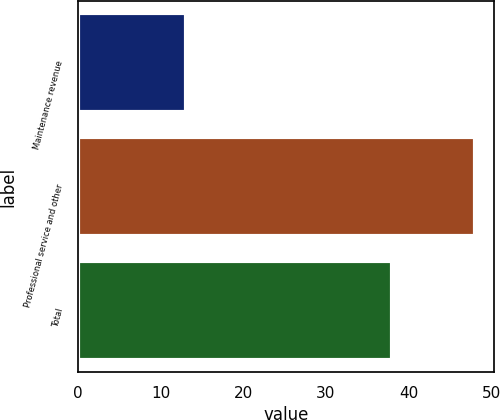Convert chart to OTSL. <chart><loc_0><loc_0><loc_500><loc_500><bar_chart><fcel>Maintenance revenue<fcel>Professional service and other<fcel>Total<nl><fcel>13<fcel>48<fcel>38<nl></chart> 